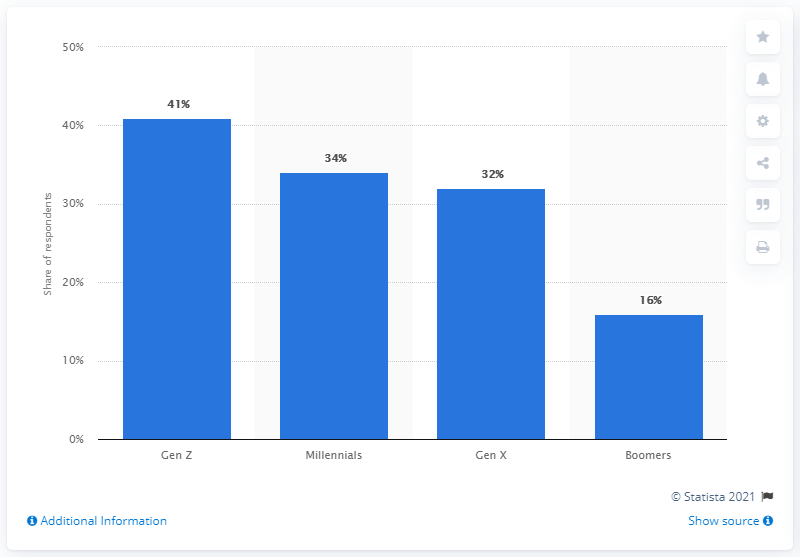List a handful of essential elements in this visual. The group that had the least amount of impulsive buyers was Generation X. According to the given information, it can be concluded that the generational group that is most likely to identify with impulsive buyers is Generation Z. 